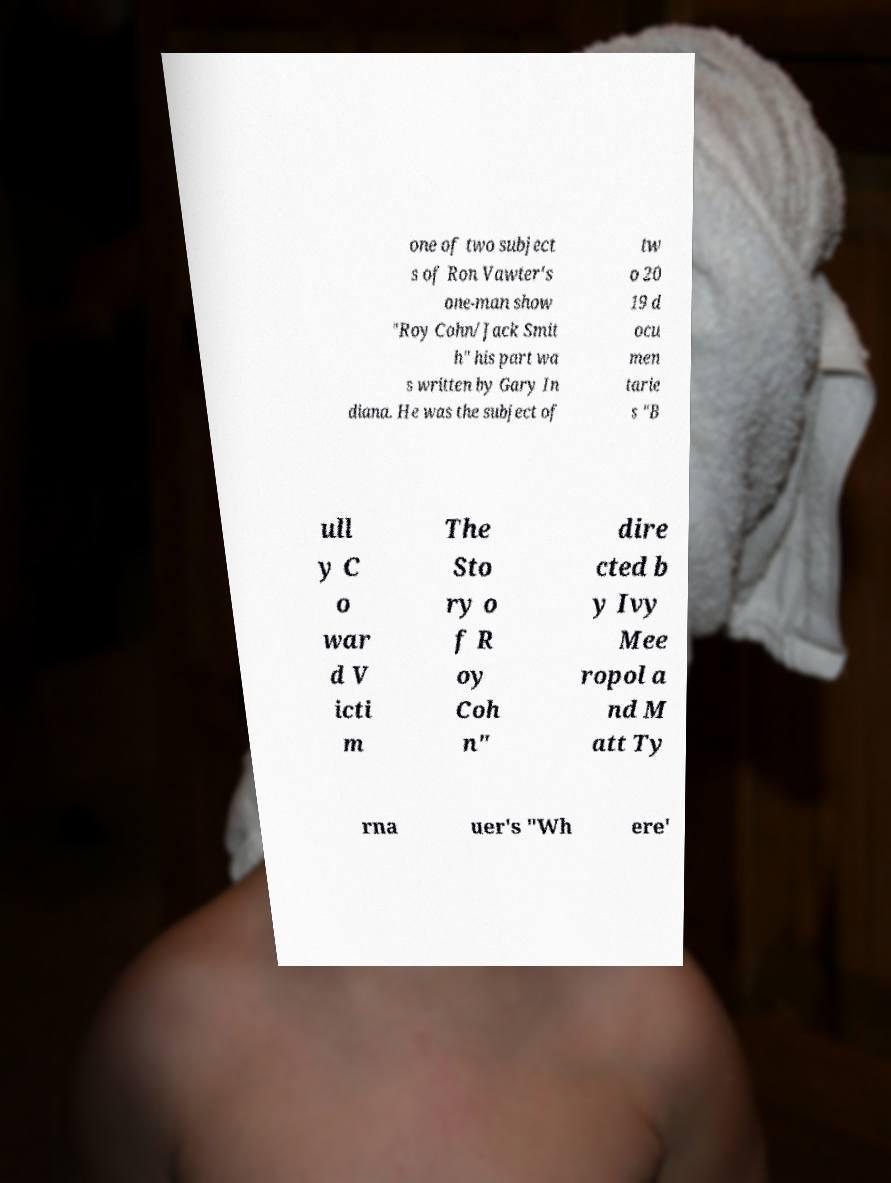For documentation purposes, I need the text within this image transcribed. Could you provide that? one of two subject s of Ron Vawter's one-man show "Roy Cohn/Jack Smit h" his part wa s written by Gary In diana. He was the subject of tw o 20 19 d ocu men tarie s "B ull y C o war d V icti m The Sto ry o f R oy Coh n" dire cted b y Ivy Mee ropol a nd M att Ty rna uer's "Wh ere' 